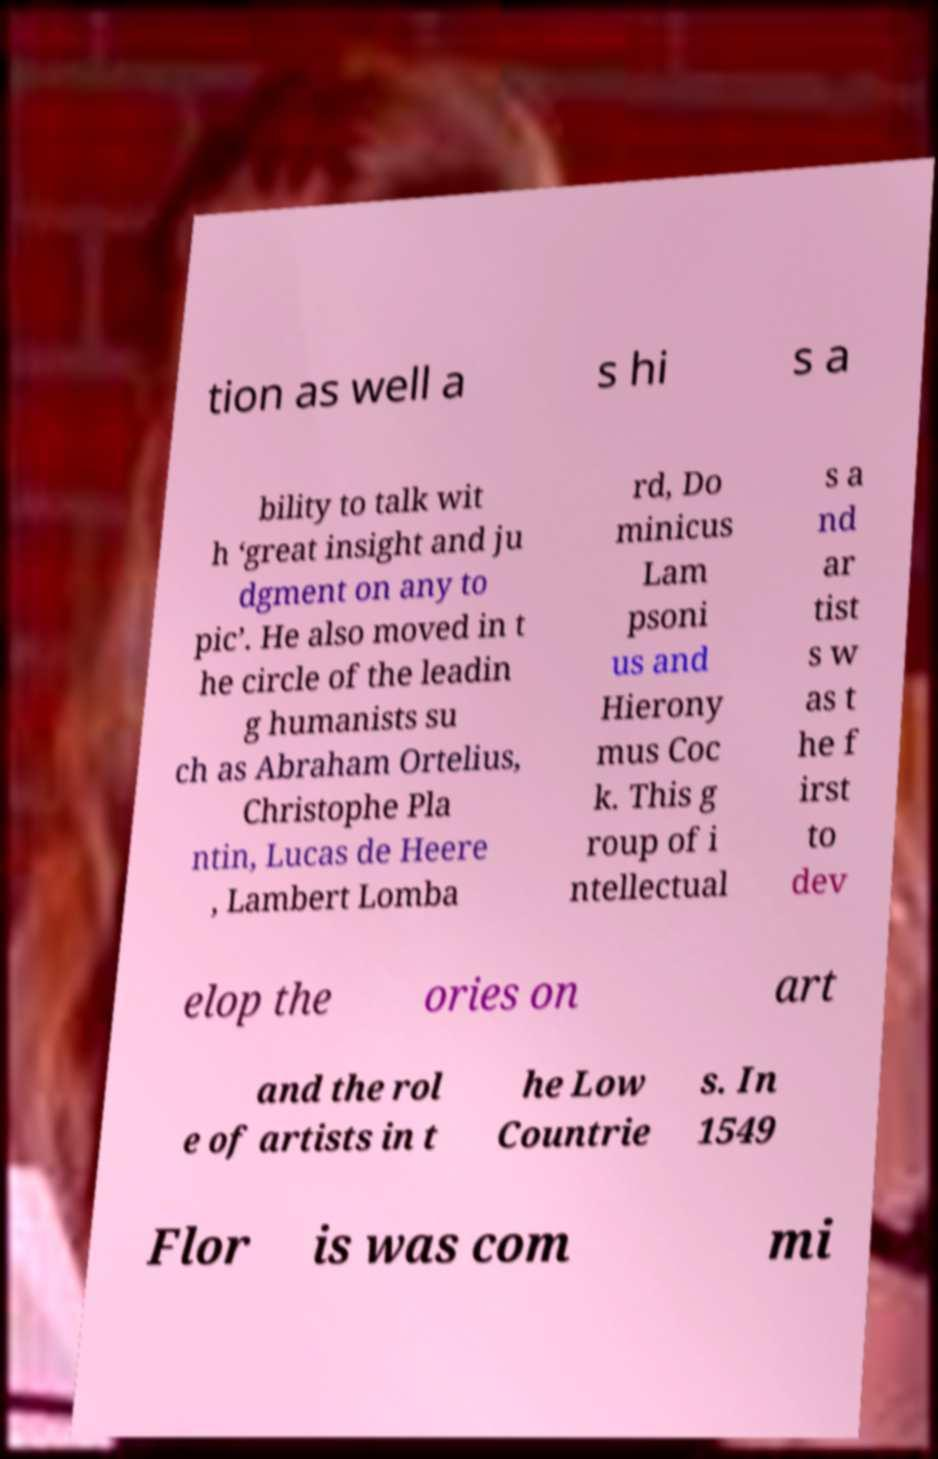Can you read and provide the text displayed in the image?This photo seems to have some interesting text. Can you extract and type it out for me? tion as well a s hi s a bility to talk wit h ‘great insight and ju dgment on any to pic’. He also moved in t he circle of the leadin g humanists su ch as Abraham Ortelius, Christophe Pla ntin, Lucas de Heere , Lambert Lomba rd, Do minicus Lam psoni us and Hierony mus Coc k. This g roup of i ntellectual s a nd ar tist s w as t he f irst to dev elop the ories on art and the rol e of artists in t he Low Countrie s. In 1549 Flor is was com mi 